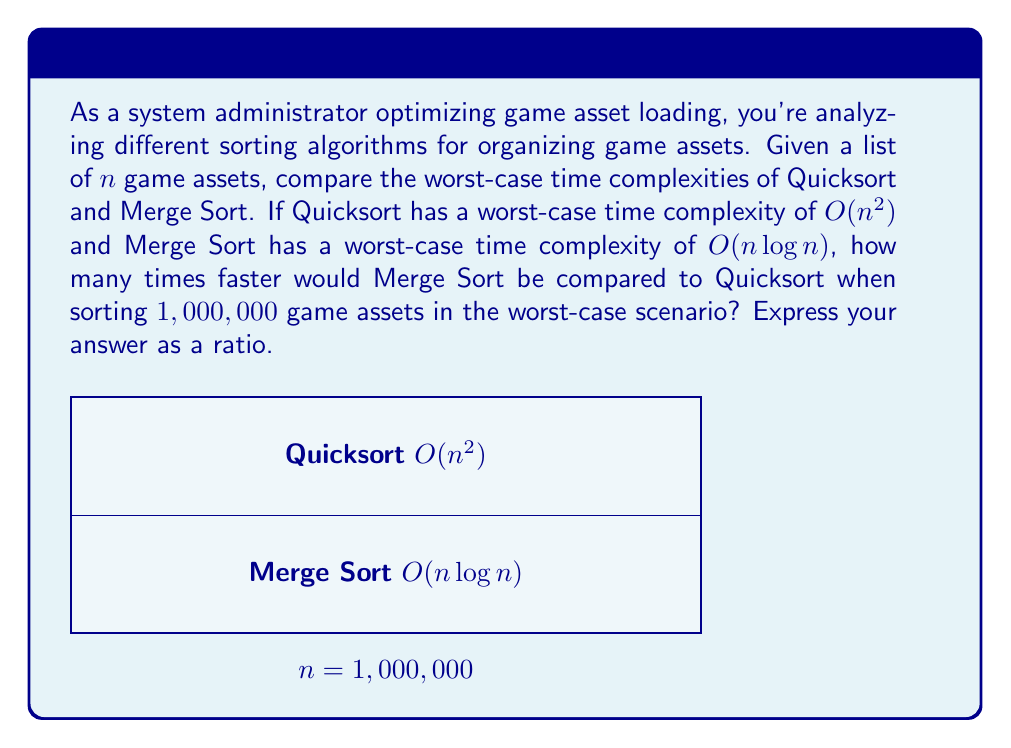Can you answer this question? Let's approach this step-by-step:

1) For Quicksort:
   Worst-case time complexity: $O(n^2)$
   With $n = 1,000,000$, this becomes:
   $$(1,000,000)^2 = 1,000,000,000,000$$

2) For Merge Sort:
   Worst-case time complexity: $O(n \log n)$
   With $n = 1,000,000$, this becomes:
   $$1,000,000 \cdot \log_2(1,000,000)$$

3) Calculate $\log_2(1,000,000)$:
   $$2^{20} = 1,048,576$$
   So, $\log_2(1,000,000)$ is slightly less than 20.
   Let's use 20 for simplification.

4) Now, Merge Sort's complexity is approximately:
   $$1,000,000 \cdot 20 = 20,000,000$$

5) To find how many times faster Merge Sort is, divide Quicksort's complexity by Merge Sort's:
   $$\frac{1,000,000,000,000}{20,000,000} = 50,000$$

Therefore, in this worst-case scenario with 1,000,000 game assets, Merge Sort would be approximately 50,000 times faster than Quicksort.
Answer: 50,000:1 